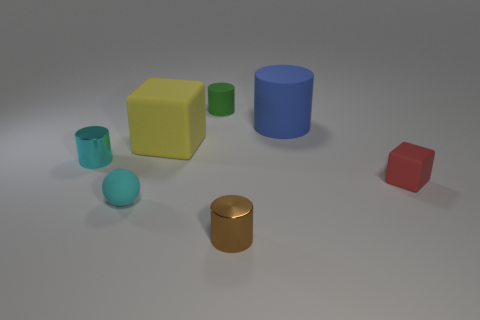How many cylinders are made of the same material as the yellow block?
Offer a terse response. 2. How many yellow things are behind the small metallic object that is behind the red rubber cube?
Your response must be concise. 1. Are there any big yellow rubber objects to the right of the big blue object?
Keep it short and to the point. No. There is a small matte object that is right of the tiny green cylinder; is its shape the same as the yellow rubber object?
Your answer should be very brief. Yes. What number of shiny things are the same color as the small sphere?
Make the answer very short. 1. There is a tiny matte object that is to the right of the object in front of the small cyan rubber ball; what is its shape?
Make the answer very short. Cube. Is there a tiny red rubber thing of the same shape as the yellow rubber object?
Give a very brief answer. Yes. Does the matte sphere have the same color as the metallic thing behind the red thing?
Make the answer very short. Yes. What is the size of the metal thing that is the same color as the small ball?
Your response must be concise. Small. Is there a blue object of the same size as the yellow matte block?
Keep it short and to the point. Yes. 